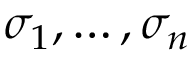<formula> <loc_0><loc_0><loc_500><loc_500>\sigma _ { 1 } , \dots , \sigma _ { n }</formula> 